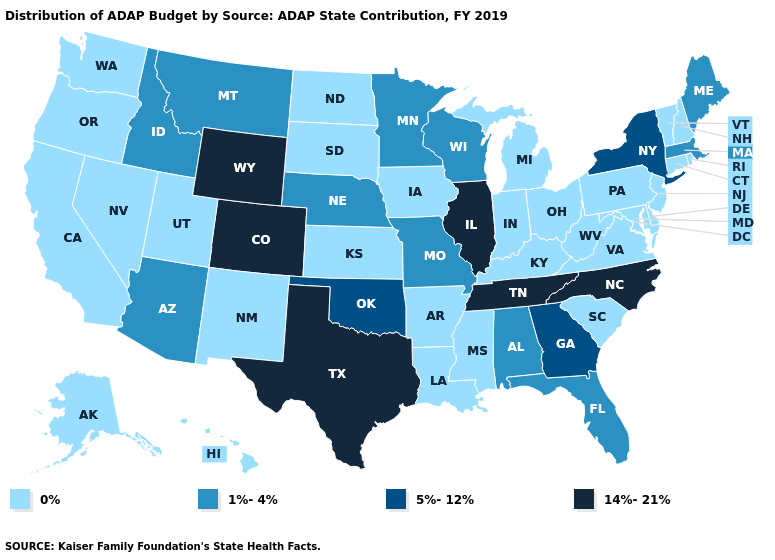What is the value of Mississippi?
Answer briefly. 0%. What is the value of California?
Answer briefly. 0%. Name the states that have a value in the range 1%-4%?
Be succinct. Alabama, Arizona, Florida, Idaho, Maine, Massachusetts, Minnesota, Missouri, Montana, Nebraska, Wisconsin. Name the states that have a value in the range 0%?
Short answer required. Alaska, Arkansas, California, Connecticut, Delaware, Hawaii, Indiana, Iowa, Kansas, Kentucky, Louisiana, Maryland, Michigan, Mississippi, Nevada, New Hampshire, New Jersey, New Mexico, North Dakota, Ohio, Oregon, Pennsylvania, Rhode Island, South Carolina, South Dakota, Utah, Vermont, Virginia, Washington, West Virginia. Does Wyoming have the lowest value in the USA?
Short answer required. No. What is the value of Washington?
Keep it brief. 0%. Which states have the highest value in the USA?
Write a very short answer. Colorado, Illinois, North Carolina, Tennessee, Texas, Wyoming. Which states have the highest value in the USA?
Write a very short answer. Colorado, Illinois, North Carolina, Tennessee, Texas, Wyoming. What is the value of Illinois?
Be succinct. 14%-21%. Name the states that have a value in the range 14%-21%?
Keep it brief. Colorado, Illinois, North Carolina, Tennessee, Texas, Wyoming. Name the states that have a value in the range 1%-4%?
Short answer required. Alabama, Arizona, Florida, Idaho, Maine, Massachusetts, Minnesota, Missouri, Montana, Nebraska, Wisconsin. Does Arizona have the highest value in the West?
Write a very short answer. No. What is the highest value in states that border Colorado?
Be succinct. 14%-21%. Does Oklahoma have the lowest value in the USA?
Concise answer only. No. What is the value of Arizona?
Keep it brief. 1%-4%. 